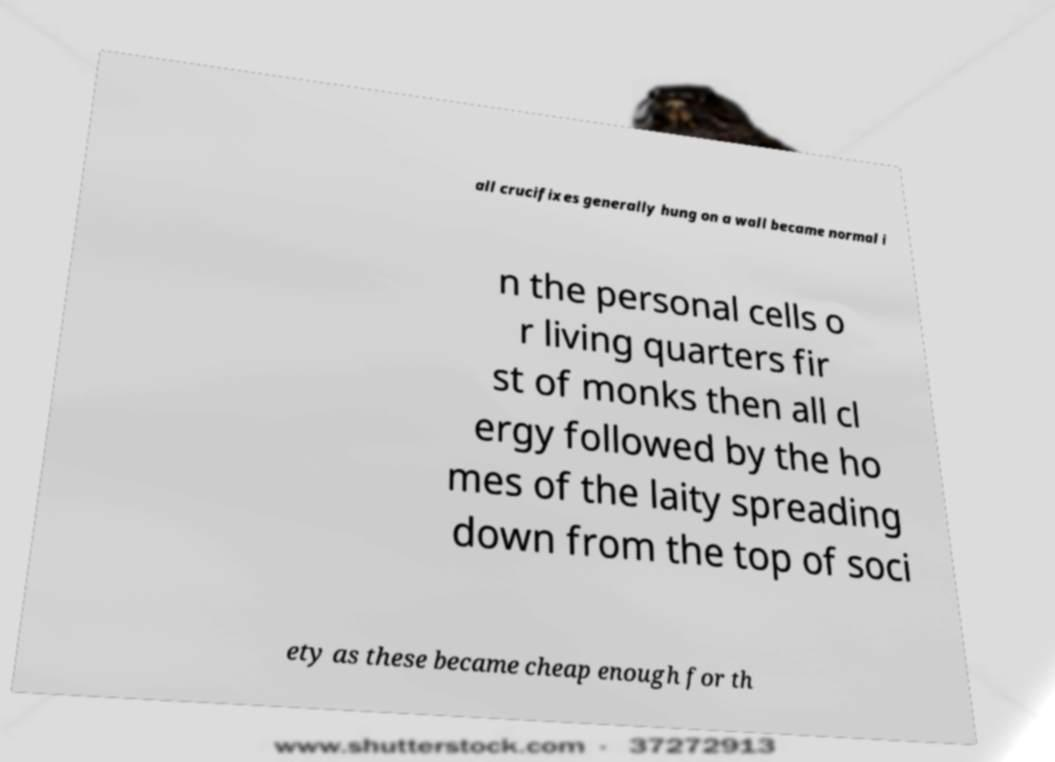What messages or text are displayed in this image? I need them in a readable, typed format. all crucifixes generally hung on a wall became normal i n the personal cells o r living quarters fir st of monks then all cl ergy followed by the ho mes of the laity spreading down from the top of soci ety as these became cheap enough for th 